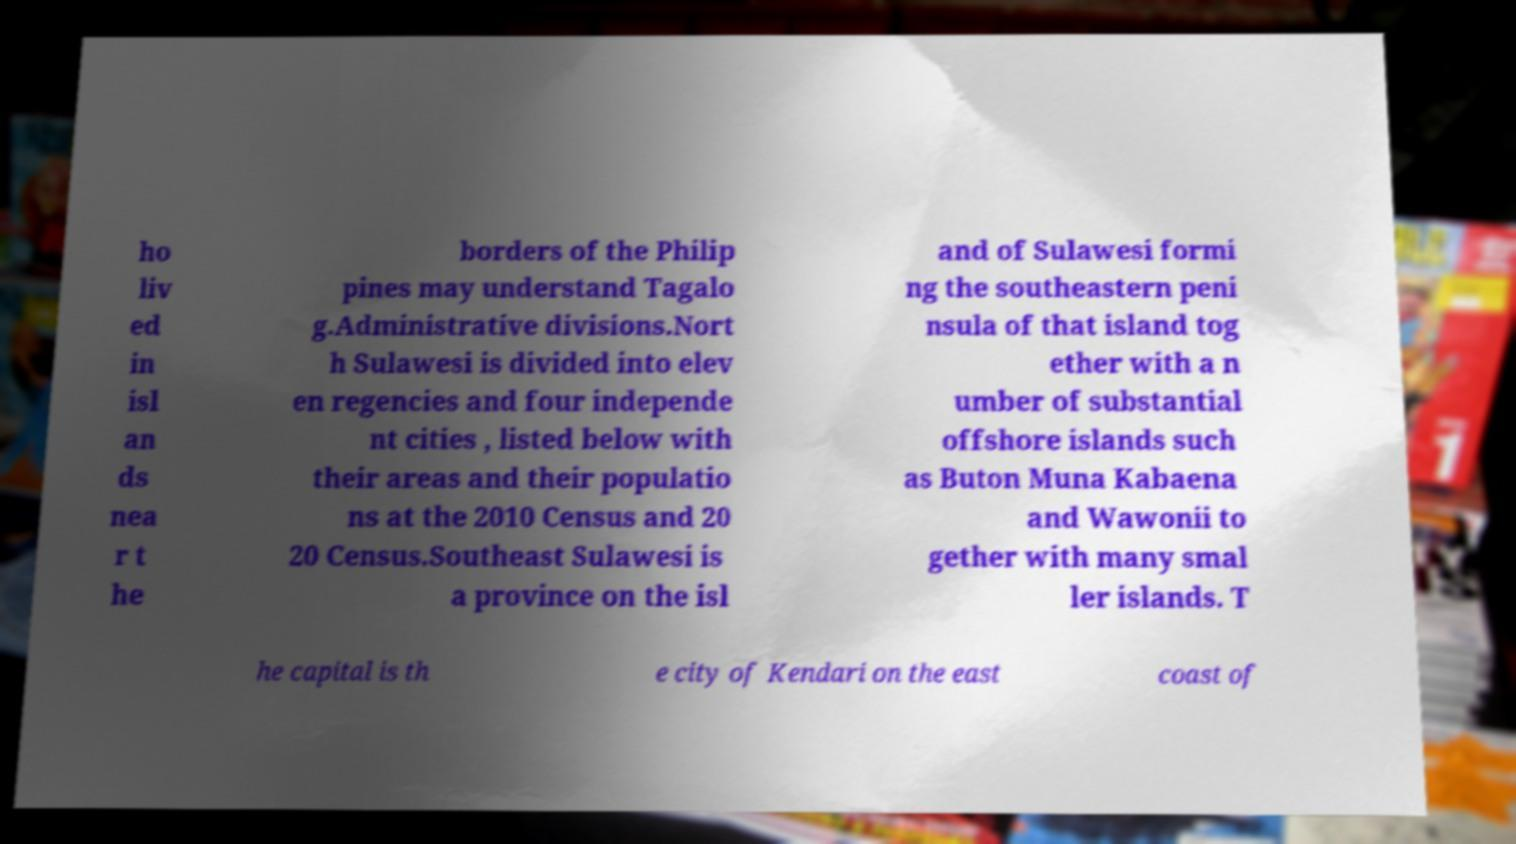What messages or text are displayed in this image? I need them in a readable, typed format. ho liv ed in isl an ds nea r t he borders of the Philip pines may understand Tagalo g.Administrative divisions.Nort h Sulawesi is divided into elev en regencies and four independe nt cities , listed below with their areas and their populatio ns at the 2010 Census and 20 20 Census.Southeast Sulawesi is a province on the isl and of Sulawesi formi ng the southeastern peni nsula of that island tog ether with a n umber of substantial offshore islands such as Buton Muna Kabaena and Wawonii to gether with many smal ler islands. T he capital is th e city of Kendari on the east coast of 